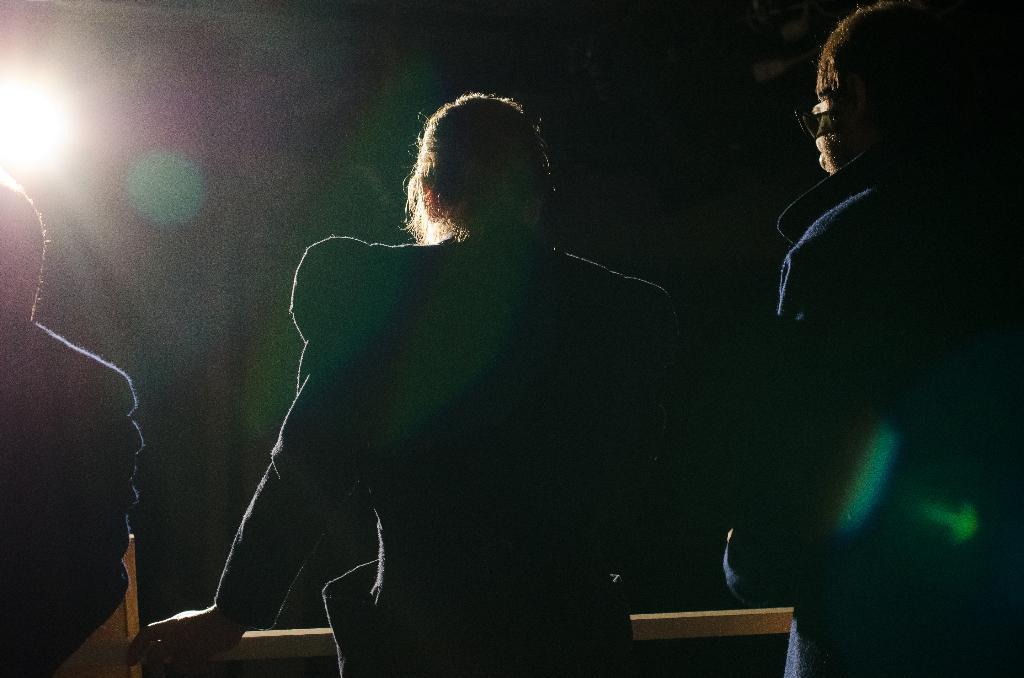How would you summarize this image in a sentence or two? In this image there are three persons, there is an object in front of the persons, there is a person truncated towards the right of the image, there is a person truncated towards the left of the image, there is a light truncated towards the left of the image, the background of the image is dark. 